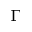<formula> <loc_0><loc_0><loc_500><loc_500>\Gamma</formula> 